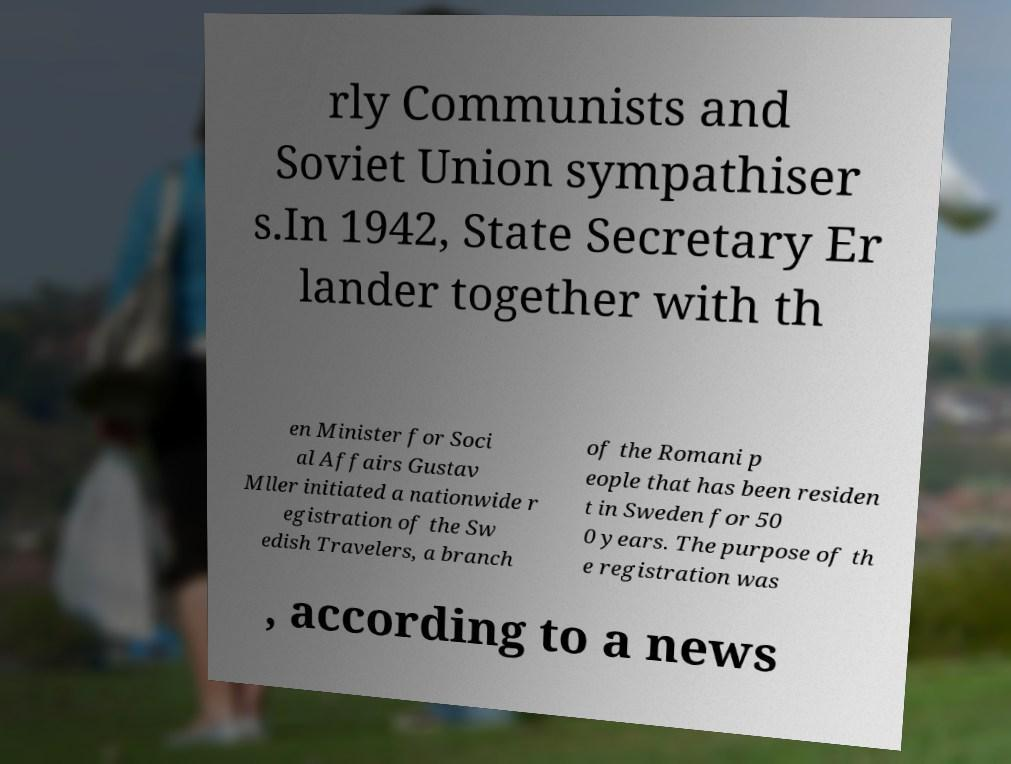What messages or text are displayed in this image? I need them in a readable, typed format. rly Communists and Soviet Union sympathiser s.In 1942, State Secretary Er lander together with th en Minister for Soci al Affairs Gustav Mller initiated a nationwide r egistration of the Sw edish Travelers, a branch of the Romani p eople that has been residen t in Sweden for 50 0 years. The purpose of th e registration was , according to a news 